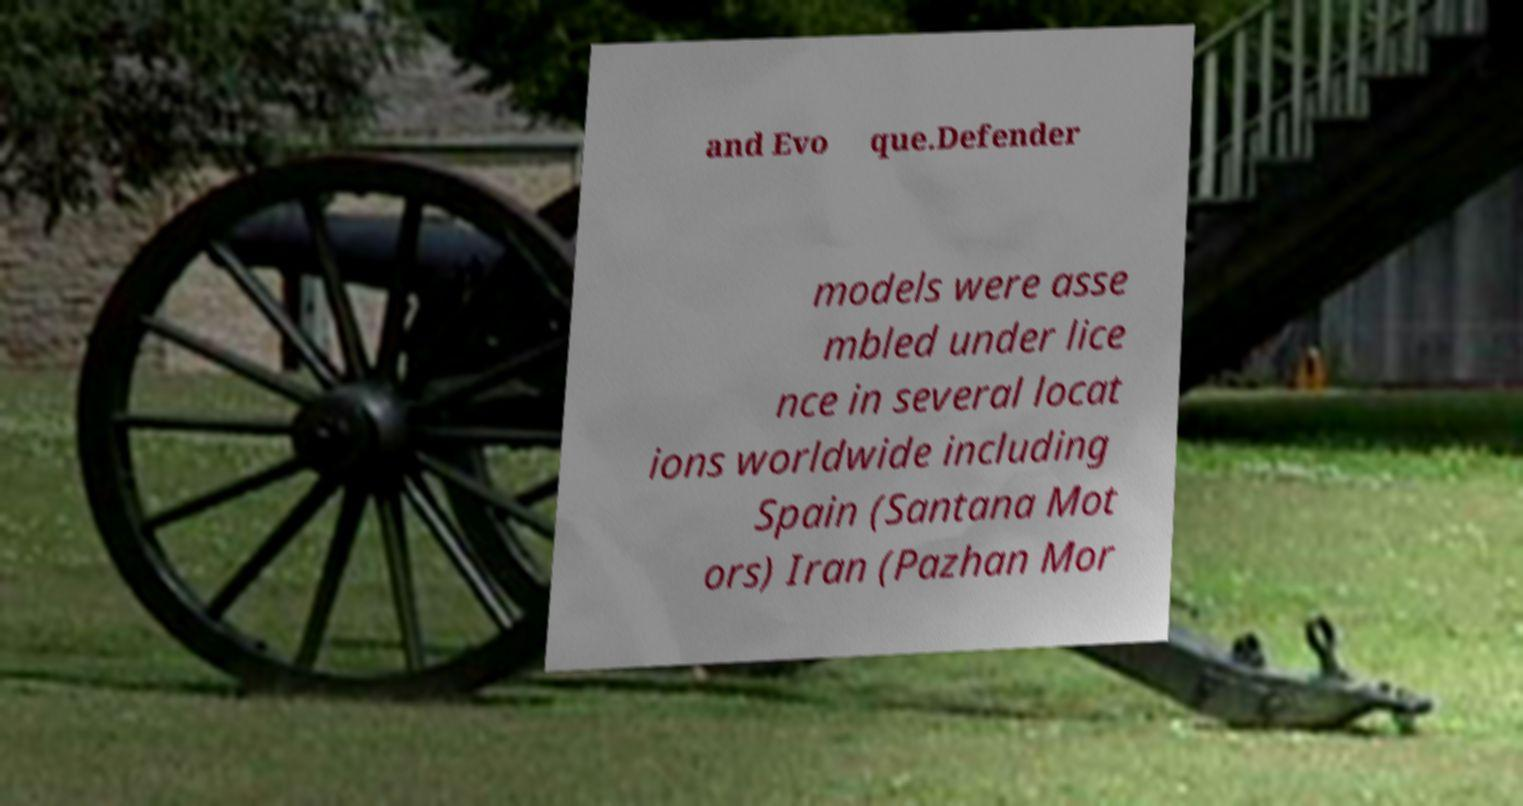Can you accurately transcribe the text from the provided image for me? and Evo que.Defender models were asse mbled under lice nce in several locat ions worldwide including Spain (Santana Mot ors) Iran (Pazhan Mor 